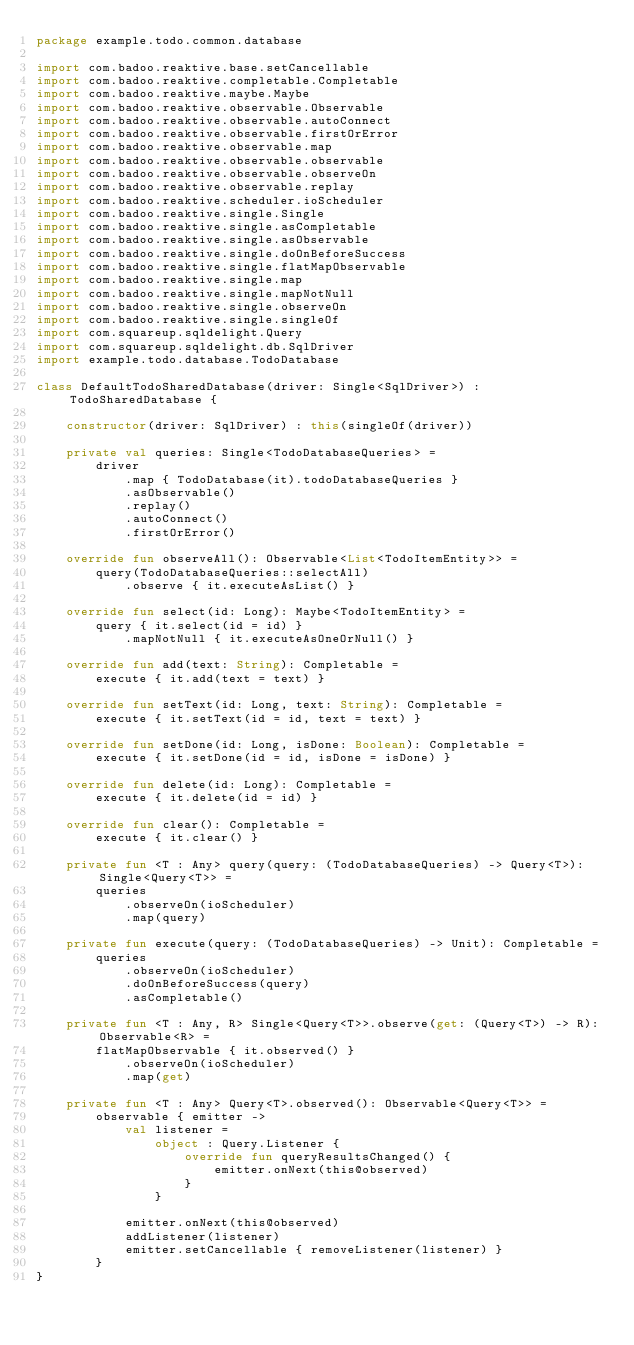<code> <loc_0><loc_0><loc_500><loc_500><_Kotlin_>package example.todo.common.database

import com.badoo.reaktive.base.setCancellable
import com.badoo.reaktive.completable.Completable
import com.badoo.reaktive.maybe.Maybe
import com.badoo.reaktive.observable.Observable
import com.badoo.reaktive.observable.autoConnect
import com.badoo.reaktive.observable.firstOrError
import com.badoo.reaktive.observable.map
import com.badoo.reaktive.observable.observable
import com.badoo.reaktive.observable.observeOn
import com.badoo.reaktive.observable.replay
import com.badoo.reaktive.scheduler.ioScheduler
import com.badoo.reaktive.single.Single
import com.badoo.reaktive.single.asCompletable
import com.badoo.reaktive.single.asObservable
import com.badoo.reaktive.single.doOnBeforeSuccess
import com.badoo.reaktive.single.flatMapObservable
import com.badoo.reaktive.single.map
import com.badoo.reaktive.single.mapNotNull
import com.badoo.reaktive.single.observeOn
import com.badoo.reaktive.single.singleOf
import com.squareup.sqldelight.Query
import com.squareup.sqldelight.db.SqlDriver
import example.todo.database.TodoDatabase

class DefaultTodoSharedDatabase(driver: Single<SqlDriver>) : TodoSharedDatabase {

    constructor(driver: SqlDriver) : this(singleOf(driver))

    private val queries: Single<TodoDatabaseQueries> =
        driver
            .map { TodoDatabase(it).todoDatabaseQueries }
            .asObservable()
            .replay()
            .autoConnect()
            .firstOrError()

    override fun observeAll(): Observable<List<TodoItemEntity>> =
        query(TodoDatabaseQueries::selectAll)
            .observe { it.executeAsList() }

    override fun select(id: Long): Maybe<TodoItemEntity> =
        query { it.select(id = id) }
            .mapNotNull { it.executeAsOneOrNull() }

    override fun add(text: String): Completable =
        execute { it.add(text = text) }

    override fun setText(id: Long, text: String): Completable =
        execute { it.setText(id = id, text = text) }

    override fun setDone(id: Long, isDone: Boolean): Completable =
        execute { it.setDone(id = id, isDone = isDone) }

    override fun delete(id: Long): Completable =
        execute { it.delete(id = id) }

    override fun clear(): Completable =
        execute { it.clear() }

    private fun <T : Any> query(query: (TodoDatabaseQueries) -> Query<T>): Single<Query<T>> =
        queries
            .observeOn(ioScheduler)
            .map(query)

    private fun execute(query: (TodoDatabaseQueries) -> Unit): Completable =
        queries
            .observeOn(ioScheduler)
            .doOnBeforeSuccess(query)
            .asCompletable()

    private fun <T : Any, R> Single<Query<T>>.observe(get: (Query<T>) -> R): Observable<R> =
        flatMapObservable { it.observed() }
            .observeOn(ioScheduler)
            .map(get)

    private fun <T : Any> Query<T>.observed(): Observable<Query<T>> =
        observable { emitter ->
            val listener =
                object : Query.Listener {
                    override fun queryResultsChanged() {
                        emitter.onNext(this@observed)
                    }
                }

            emitter.onNext(this@observed)
            addListener(listener)
            emitter.setCancellable { removeListener(listener) }
        }
}
</code> 